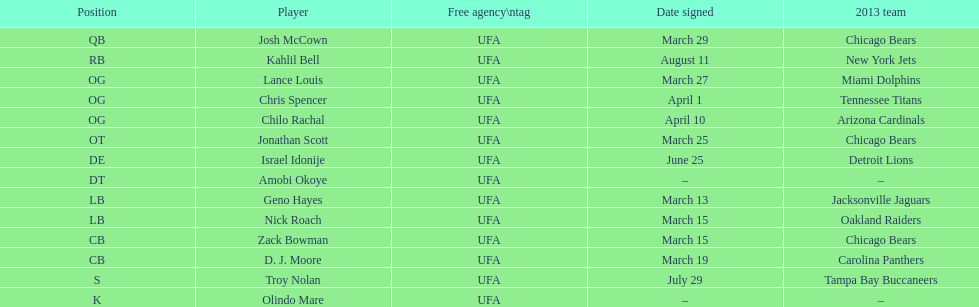What last name can also function as a first name and begins with the letter "n"? Troy Nolan. Can you parse all the data within this table? {'header': ['Position', 'Player', 'Free agency\\ntag', 'Date signed', '2013 team'], 'rows': [['QB', 'Josh McCown', 'UFA', 'March 29', 'Chicago Bears'], ['RB', 'Kahlil Bell', 'UFA', 'August 11', 'New York Jets'], ['OG', 'Lance Louis', 'UFA', 'March 27', 'Miami Dolphins'], ['OG', 'Chris Spencer', 'UFA', 'April 1', 'Tennessee Titans'], ['OG', 'Chilo Rachal', 'UFA', 'April 10', 'Arizona Cardinals'], ['OT', 'Jonathan Scott', 'UFA', 'March 25', 'Chicago Bears'], ['DE', 'Israel Idonije', 'UFA', 'June 25', 'Detroit Lions'], ['DT', 'Amobi Okoye', 'UFA', '–', '–'], ['LB', 'Geno Hayes', 'UFA', 'March 13', 'Jacksonville Jaguars'], ['LB', 'Nick Roach', 'UFA', 'March 15', 'Oakland Raiders'], ['CB', 'Zack Bowman', 'UFA', 'March 15', 'Chicago Bears'], ['CB', 'D. J. Moore', 'UFA', 'March 19', 'Carolina Panthers'], ['S', 'Troy Nolan', 'UFA', 'July 29', 'Tampa Bay Buccaneers'], ['K', 'Olindo Mare', 'UFA', '–', '–']]} 